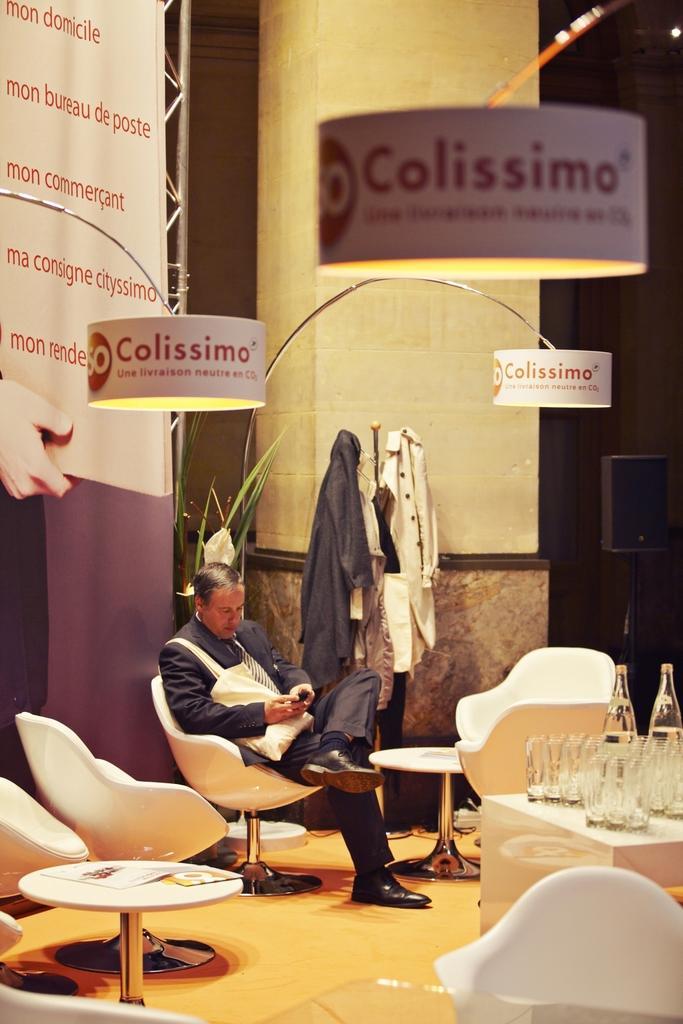Please provide a concise description of this image. There is a man sitting in a chair. In front of him there are some glasses and bottles on the table. In the background there are some coats. We can observe a wall and a pillar here. 